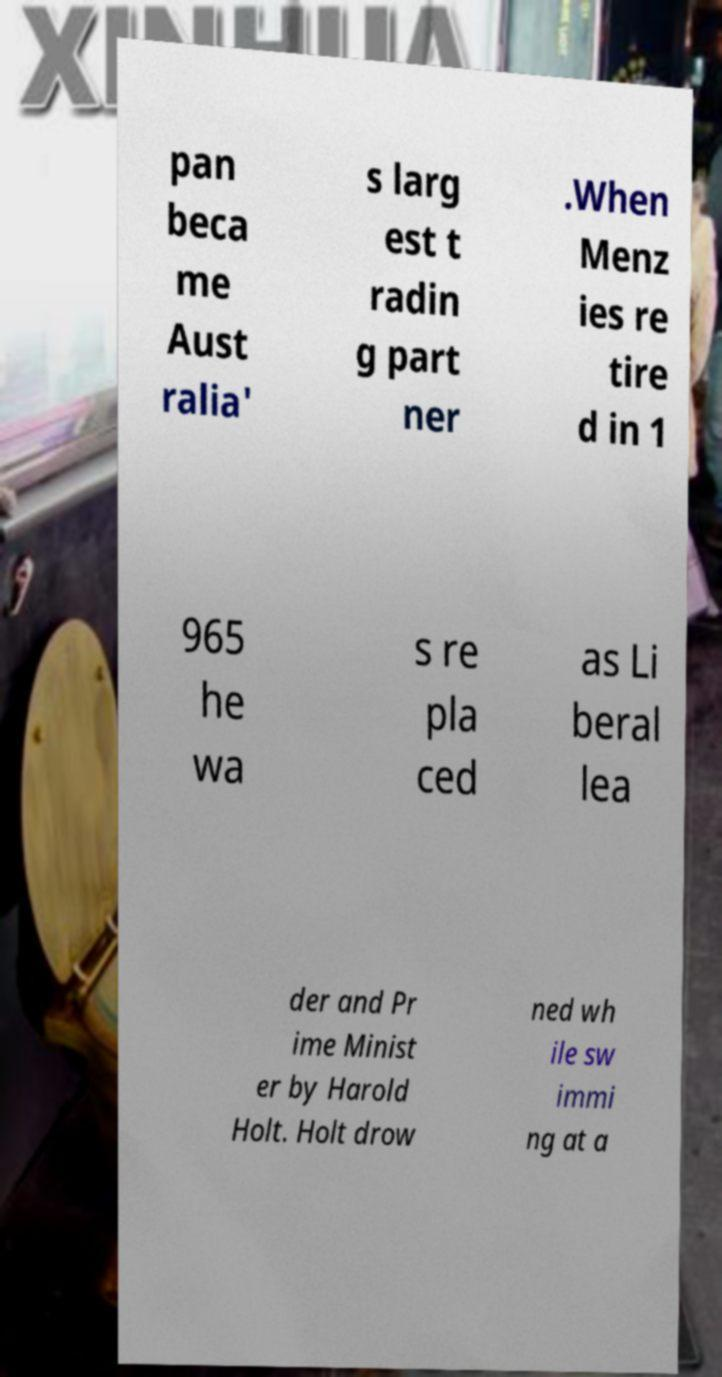There's text embedded in this image that I need extracted. Can you transcribe it verbatim? pan beca me Aust ralia' s larg est t radin g part ner .When Menz ies re tire d in 1 965 he wa s re pla ced as Li beral lea der and Pr ime Minist er by Harold Holt. Holt drow ned wh ile sw immi ng at a 